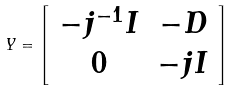Convert formula to latex. <formula><loc_0><loc_0><loc_500><loc_500>Y = \left [ \begin{array} { c c } - j ^ { - 1 } I & - D \\ 0 & - j I \end{array} \right ]</formula> 